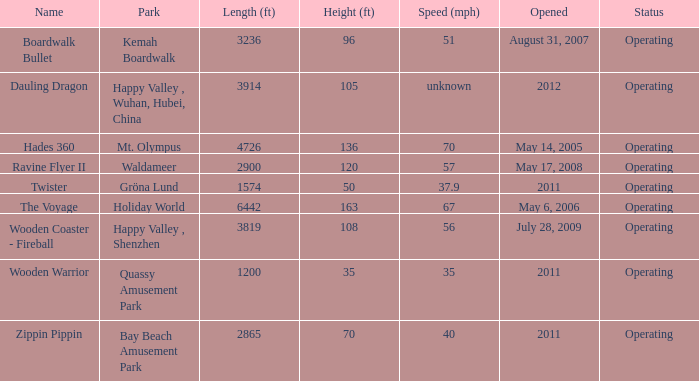What is the number of parks where zippin pippin is situated? 1.0. 